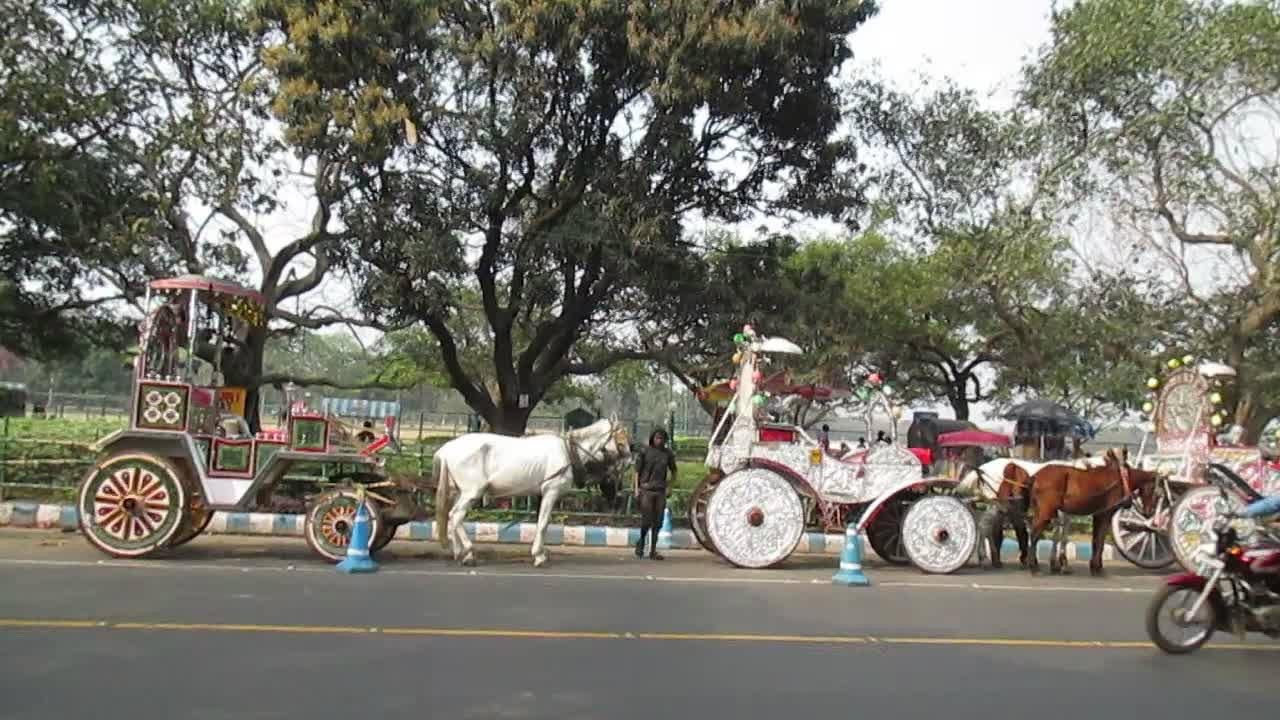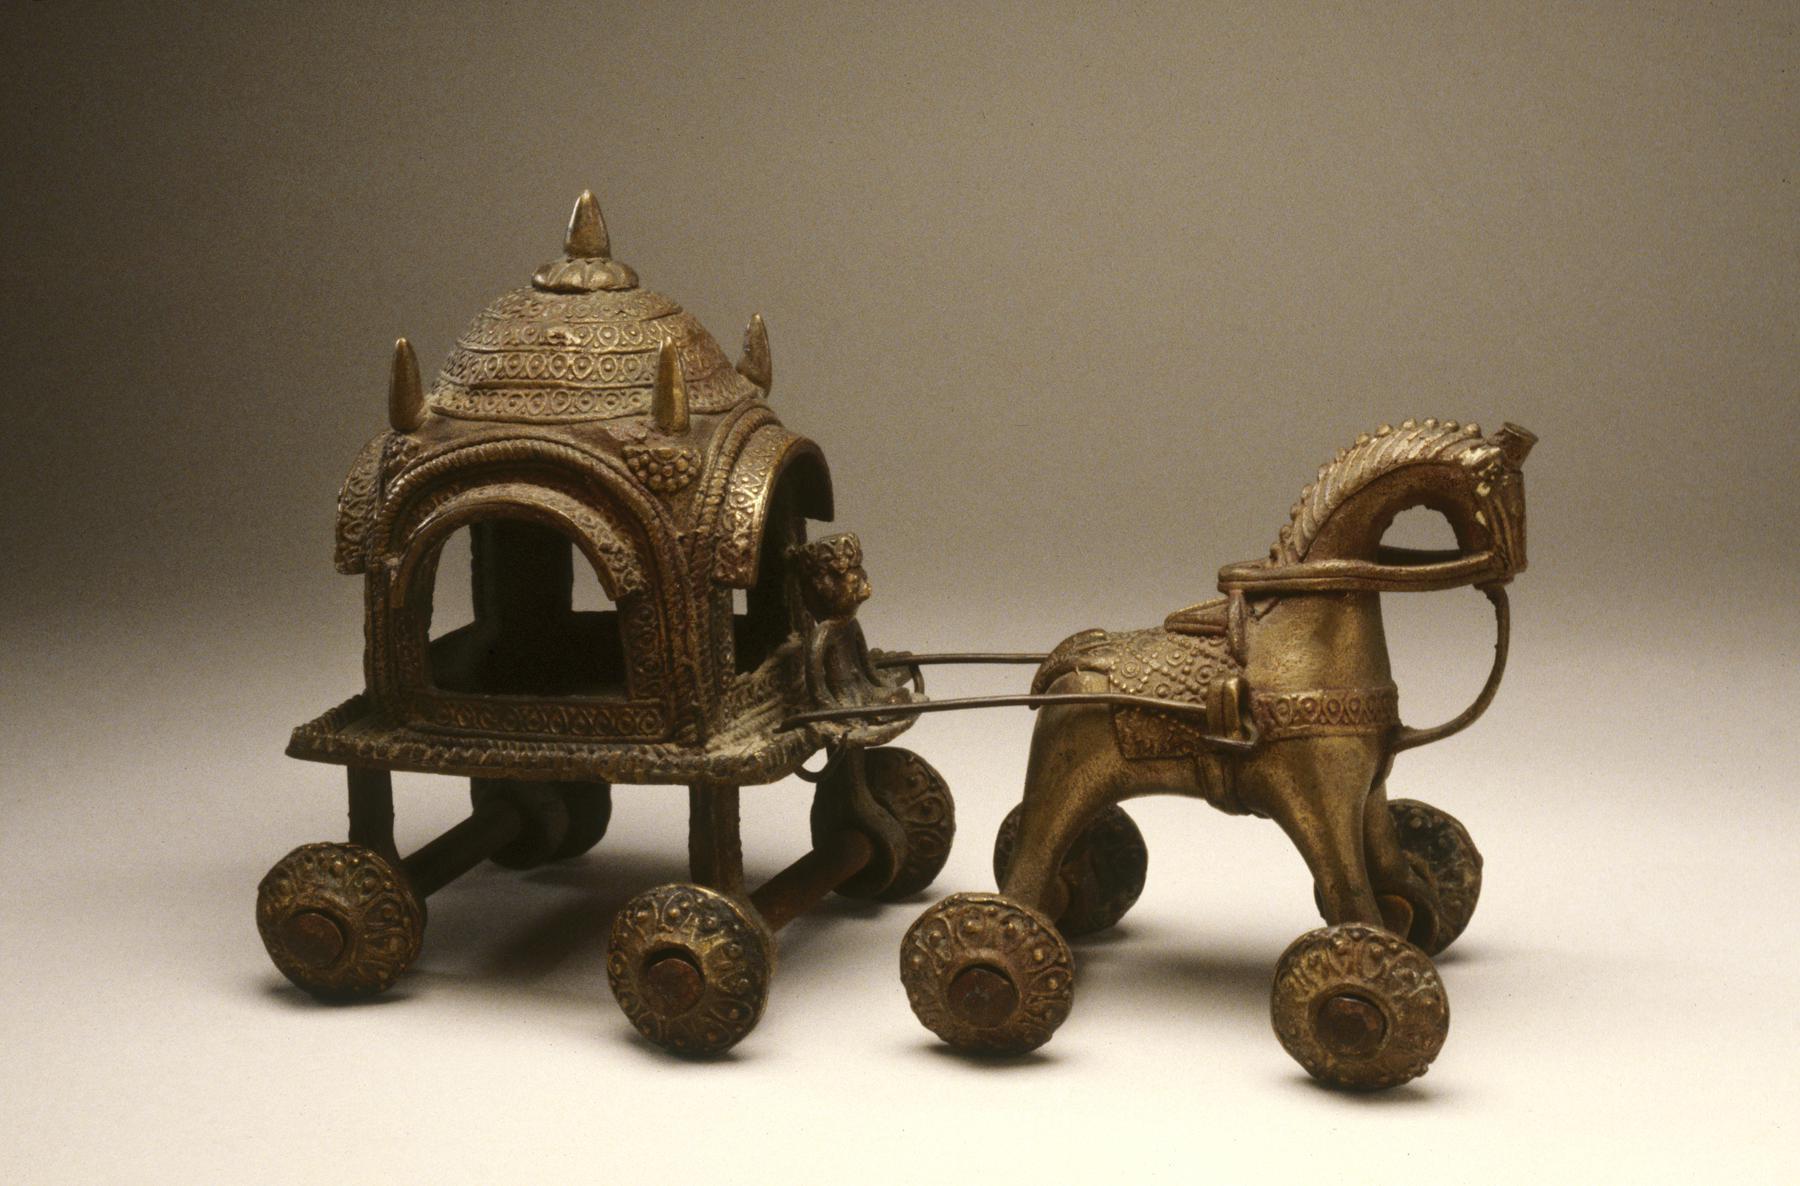The first image is the image on the left, the second image is the image on the right. For the images displayed, is the sentence "An image shows a leftward-headed wagon with ornate white wheels, pulled by at least one white horse." factually correct? Answer yes or no. No. The first image is the image on the left, the second image is the image on the right. Assess this claim about the two images: "A car is behind a horse carriage.". Correct or not? Answer yes or no. No. 